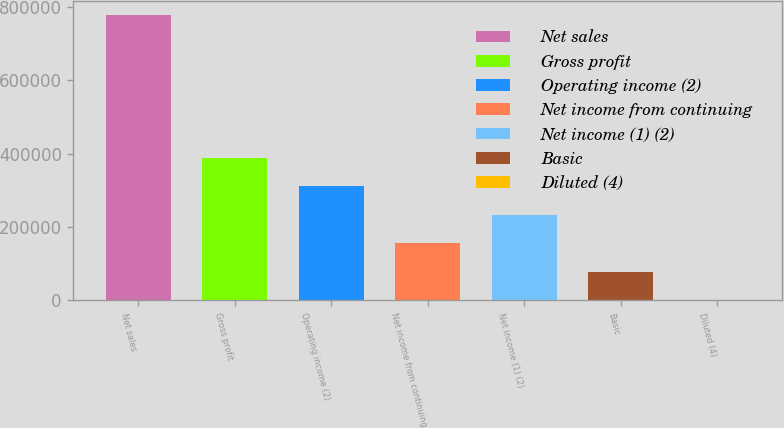Convert chart to OTSL. <chart><loc_0><loc_0><loc_500><loc_500><bar_chart><fcel>Net sales<fcel>Gross profit<fcel>Operating income (2)<fcel>Net income from continuing<fcel>Net income (1) (2)<fcel>Basic<fcel>Diluted (4)<nl><fcel>776166<fcel>388083<fcel>310467<fcel>155234<fcel>232850<fcel>77617.3<fcel>0.74<nl></chart> 